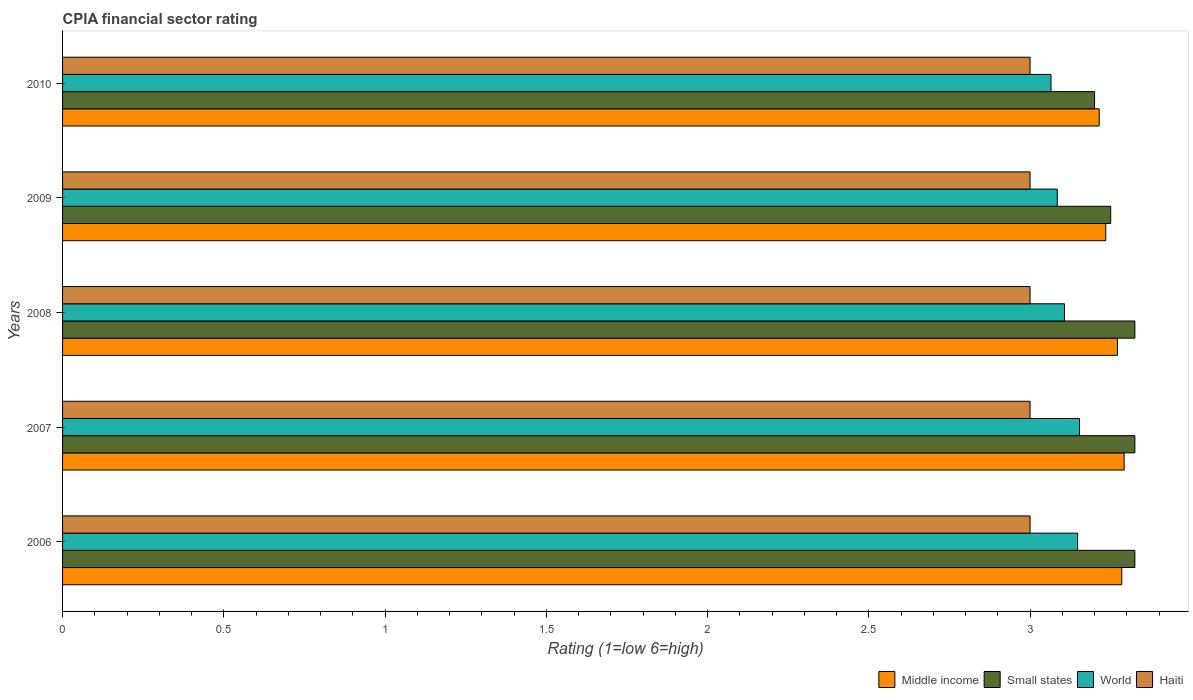Are the number of bars per tick equal to the number of legend labels?
Offer a terse response. Yes. In how many cases, is the number of bars for a given year not equal to the number of legend labels?
Make the answer very short. 0. What is the CPIA rating in World in 2008?
Your answer should be very brief. 3.11. Across all years, what is the maximum CPIA rating in Small states?
Offer a terse response. 3.33. Across all years, what is the minimum CPIA rating in Haiti?
Your response must be concise. 3. In which year was the CPIA rating in World maximum?
Give a very brief answer. 2007. What is the total CPIA rating in Middle income in the graph?
Your response must be concise. 16.3. What is the difference between the CPIA rating in Small states in 2007 and that in 2009?
Make the answer very short. 0.08. What is the difference between the CPIA rating in Middle income in 2009 and the CPIA rating in Small states in 2007?
Your answer should be very brief. -0.09. What is the average CPIA rating in Small states per year?
Offer a very short reply. 3.29. In the year 2008, what is the difference between the CPIA rating in World and CPIA rating in Haiti?
Your response must be concise. 0.11. What is the ratio of the CPIA rating in Small states in 2006 to that in 2007?
Your response must be concise. 1. Is the CPIA rating in World in 2006 less than that in 2007?
Ensure brevity in your answer.  Yes. Is the difference between the CPIA rating in World in 2009 and 2010 greater than the difference between the CPIA rating in Haiti in 2009 and 2010?
Your answer should be compact. Yes. What is the difference between the highest and the second highest CPIA rating in Haiti?
Your answer should be very brief. 0. Is it the case that in every year, the sum of the CPIA rating in Small states and CPIA rating in World is greater than the sum of CPIA rating in Haiti and CPIA rating in Middle income?
Make the answer very short. Yes. What does the 4th bar from the top in 2007 represents?
Make the answer very short. Middle income. Is it the case that in every year, the sum of the CPIA rating in Haiti and CPIA rating in Middle income is greater than the CPIA rating in Small states?
Ensure brevity in your answer.  Yes. How many bars are there?
Give a very brief answer. 20. What is the difference between two consecutive major ticks on the X-axis?
Keep it short and to the point. 0.5. Are the values on the major ticks of X-axis written in scientific E-notation?
Offer a terse response. No. Does the graph contain any zero values?
Ensure brevity in your answer.  No. Where does the legend appear in the graph?
Offer a terse response. Bottom right. How many legend labels are there?
Your response must be concise. 4. What is the title of the graph?
Ensure brevity in your answer.  CPIA financial sector rating. Does "Palau" appear as one of the legend labels in the graph?
Provide a succinct answer. No. What is the label or title of the X-axis?
Your answer should be compact. Rating (1=low 6=high). What is the label or title of the Y-axis?
Keep it short and to the point. Years. What is the Rating (1=low 6=high) of Middle income in 2006?
Keep it short and to the point. 3.28. What is the Rating (1=low 6=high) of Small states in 2006?
Your response must be concise. 3.33. What is the Rating (1=low 6=high) of World in 2006?
Make the answer very short. 3.15. What is the Rating (1=low 6=high) in Haiti in 2006?
Give a very brief answer. 3. What is the Rating (1=low 6=high) of Middle income in 2007?
Provide a succinct answer. 3.29. What is the Rating (1=low 6=high) in Small states in 2007?
Offer a terse response. 3.33. What is the Rating (1=low 6=high) in World in 2007?
Make the answer very short. 3.15. What is the Rating (1=low 6=high) of Middle income in 2008?
Your answer should be compact. 3.27. What is the Rating (1=low 6=high) of Small states in 2008?
Offer a very short reply. 3.33. What is the Rating (1=low 6=high) of World in 2008?
Your response must be concise. 3.11. What is the Rating (1=low 6=high) in Middle income in 2009?
Provide a succinct answer. 3.23. What is the Rating (1=low 6=high) of World in 2009?
Give a very brief answer. 3.08. What is the Rating (1=low 6=high) in Haiti in 2009?
Your answer should be compact. 3. What is the Rating (1=low 6=high) in Middle income in 2010?
Give a very brief answer. 3.21. What is the Rating (1=low 6=high) in Small states in 2010?
Provide a short and direct response. 3.2. What is the Rating (1=low 6=high) of World in 2010?
Provide a succinct answer. 3.06. What is the Rating (1=low 6=high) in Haiti in 2010?
Make the answer very short. 3. Across all years, what is the maximum Rating (1=low 6=high) of Middle income?
Your answer should be very brief. 3.29. Across all years, what is the maximum Rating (1=low 6=high) in Small states?
Offer a terse response. 3.33. Across all years, what is the maximum Rating (1=low 6=high) of World?
Your answer should be very brief. 3.15. Across all years, what is the minimum Rating (1=low 6=high) in Middle income?
Make the answer very short. 3.21. Across all years, what is the minimum Rating (1=low 6=high) in Small states?
Your answer should be compact. 3.2. Across all years, what is the minimum Rating (1=low 6=high) of World?
Your answer should be compact. 3.06. Across all years, what is the minimum Rating (1=low 6=high) of Haiti?
Provide a succinct answer. 3. What is the total Rating (1=low 6=high) in Middle income in the graph?
Your answer should be compact. 16.3. What is the total Rating (1=low 6=high) of Small states in the graph?
Your answer should be very brief. 16.43. What is the total Rating (1=low 6=high) of World in the graph?
Your response must be concise. 15.56. What is the difference between the Rating (1=low 6=high) of Middle income in 2006 and that in 2007?
Ensure brevity in your answer.  -0.01. What is the difference between the Rating (1=low 6=high) in World in 2006 and that in 2007?
Give a very brief answer. -0.01. What is the difference between the Rating (1=low 6=high) in Haiti in 2006 and that in 2007?
Provide a succinct answer. 0. What is the difference between the Rating (1=low 6=high) in Middle income in 2006 and that in 2008?
Ensure brevity in your answer.  0.01. What is the difference between the Rating (1=low 6=high) of World in 2006 and that in 2008?
Keep it short and to the point. 0.04. What is the difference between the Rating (1=low 6=high) in Haiti in 2006 and that in 2008?
Provide a short and direct response. 0. What is the difference between the Rating (1=low 6=high) in Middle income in 2006 and that in 2009?
Keep it short and to the point. 0.05. What is the difference between the Rating (1=low 6=high) in Small states in 2006 and that in 2009?
Ensure brevity in your answer.  0.07. What is the difference between the Rating (1=low 6=high) in World in 2006 and that in 2009?
Make the answer very short. 0.06. What is the difference between the Rating (1=low 6=high) in Haiti in 2006 and that in 2009?
Your answer should be very brief. 0. What is the difference between the Rating (1=low 6=high) in Middle income in 2006 and that in 2010?
Provide a short and direct response. 0.07. What is the difference between the Rating (1=low 6=high) in World in 2006 and that in 2010?
Give a very brief answer. 0.08. What is the difference between the Rating (1=low 6=high) of Middle income in 2007 and that in 2008?
Your answer should be compact. 0.02. What is the difference between the Rating (1=low 6=high) of World in 2007 and that in 2008?
Offer a very short reply. 0.05. What is the difference between the Rating (1=low 6=high) of Middle income in 2007 and that in 2009?
Ensure brevity in your answer.  0.06. What is the difference between the Rating (1=low 6=high) in Small states in 2007 and that in 2009?
Your answer should be very brief. 0.07. What is the difference between the Rating (1=low 6=high) of World in 2007 and that in 2009?
Keep it short and to the point. 0.07. What is the difference between the Rating (1=low 6=high) of Middle income in 2007 and that in 2010?
Your answer should be very brief. 0.08. What is the difference between the Rating (1=low 6=high) in Small states in 2007 and that in 2010?
Give a very brief answer. 0.12. What is the difference between the Rating (1=low 6=high) of World in 2007 and that in 2010?
Provide a short and direct response. 0.09. What is the difference between the Rating (1=low 6=high) of Middle income in 2008 and that in 2009?
Provide a short and direct response. 0.04. What is the difference between the Rating (1=low 6=high) in Small states in 2008 and that in 2009?
Offer a terse response. 0.07. What is the difference between the Rating (1=low 6=high) of World in 2008 and that in 2009?
Offer a very short reply. 0.02. What is the difference between the Rating (1=low 6=high) of Haiti in 2008 and that in 2009?
Keep it short and to the point. 0. What is the difference between the Rating (1=low 6=high) in Middle income in 2008 and that in 2010?
Provide a succinct answer. 0.06. What is the difference between the Rating (1=low 6=high) in World in 2008 and that in 2010?
Give a very brief answer. 0.04. What is the difference between the Rating (1=low 6=high) of Middle income in 2009 and that in 2010?
Keep it short and to the point. 0.02. What is the difference between the Rating (1=low 6=high) in World in 2009 and that in 2010?
Your answer should be compact. 0.02. What is the difference between the Rating (1=low 6=high) in Haiti in 2009 and that in 2010?
Ensure brevity in your answer.  0. What is the difference between the Rating (1=low 6=high) in Middle income in 2006 and the Rating (1=low 6=high) in Small states in 2007?
Keep it short and to the point. -0.04. What is the difference between the Rating (1=low 6=high) in Middle income in 2006 and the Rating (1=low 6=high) in World in 2007?
Your answer should be very brief. 0.13. What is the difference between the Rating (1=low 6=high) of Middle income in 2006 and the Rating (1=low 6=high) of Haiti in 2007?
Your answer should be very brief. 0.28. What is the difference between the Rating (1=low 6=high) of Small states in 2006 and the Rating (1=low 6=high) of World in 2007?
Give a very brief answer. 0.17. What is the difference between the Rating (1=low 6=high) of Small states in 2006 and the Rating (1=low 6=high) of Haiti in 2007?
Your answer should be compact. 0.33. What is the difference between the Rating (1=low 6=high) of World in 2006 and the Rating (1=low 6=high) of Haiti in 2007?
Make the answer very short. 0.15. What is the difference between the Rating (1=low 6=high) of Middle income in 2006 and the Rating (1=low 6=high) of Small states in 2008?
Your answer should be very brief. -0.04. What is the difference between the Rating (1=low 6=high) in Middle income in 2006 and the Rating (1=low 6=high) in World in 2008?
Keep it short and to the point. 0.18. What is the difference between the Rating (1=low 6=high) in Middle income in 2006 and the Rating (1=low 6=high) in Haiti in 2008?
Offer a very short reply. 0.28. What is the difference between the Rating (1=low 6=high) of Small states in 2006 and the Rating (1=low 6=high) of World in 2008?
Your answer should be compact. 0.22. What is the difference between the Rating (1=low 6=high) in Small states in 2006 and the Rating (1=low 6=high) in Haiti in 2008?
Provide a succinct answer. 0.33. What is the difference between the Rating (1=low 6=high) of World in 2006 and the Rating (1=low 6=high) of Haiti in 2008?
Make the answer very short. 0.15. What is the difference between the Rating (1=low 6=high) of Middle income in 2006 and the Rating (1=low 6=high) of Small states in 2009?
Offer a very short reply. 0.03. What is the difference between the Rating (1=low 6=high) in Middle income in 2006 and the Rating (1=low 6=high) in World in 2009?
Offer a terse response. 0.2. What is the difference between the Rating (1=low 6=high) of Middle income in 2006 and the Rating (1=low 6=high) of Haiti in 2009?
Your response must be concise. 0.28. What is the difference between the Rating (1=low 6=high) in Small states in 2006 and the Rating (1=low 6=high) in World in 2009?
Your answer should be compact. 0.24. What is the difference between the Rating (1=low 6=high) in Small states in 2006 and the Rating (1=low 6=high) in Haiti in 2009?
Your response must be concise. 0.33. What is the difference between the Rating (1=low 6=high) in World in 2006 and the Rating (1=low 6=high) in Haiti in 2009?
Give a very brief answer. 0.15. What is the difference between the Rating (1=low 6=high) in Middle income in 2006 and the Rating (1=low 6=high) in Small states in 2010?
Provide a short and direct response. 0.08. What is the difference between the Rating (1=low 6=high) of Middle income in 2006 and the Rating (1=low 6=high) of World in 2010?
Offer a very short reply. 0.22. What is the difference between the Rating (1=low 6=high) in Middle income in 2006 and the Rating (1=low 6=high) in Haiti in 2010?
Make the answer very short. 0.28. What is the difference between the Rating (1=low 6=high) of Small states in 2006 and the Rating (1=low 6=high) of World in 2010?
Offer a very short reply. 0.26. What is the difference between the Rating (1=low 6=high) of Small states in 2006 and the Rating (1=low 6=high) of Haiti in 2010?
Give a very brief answer. 0.33. What is the difference between the Rating (1=low 6=high) in World in 2006 and the Rating (1=low 6=high) in Haiti in 2010?
Give a very brief answer. 0.15. What is the difference between the Rating (1=low 6=high) in Middle income in 2007 and the Rating (1=low 6=high) in Small states in 2008?
Keep it short and to the point. -0.03. What is the difference between the Rating (1=low 6=high) in Middle income in 2007 and the Rating (1=low 6=high) in World in 2008?
Your answer should be compact. 0.18. What is the difference between the Rating (1=low 6=high) of Middle income in 2007 and the Rating (1=low 6=high) of Haiti in 2008?
Your answer should be very brief. 0.29. What is the difference between the Rating (1=low 6=high) of Small states in 2007 and the Rating (1=low 6=high) of World in 2008?
Give a very brief answer. 0.22. What is the difference between the Rating (1=low 6=high) of Small states in 2007 and the Rating (1=low 6=high) of Haiti in 2008?
Your answer should be very brief. 0.33. What is the difference between the Rating (1=low 6=high) of World in 2007 and the Rating (1=low 6=high) of Haiti in 2008?
Provide a short and direct response. 0.15. What is the difference between the Rating (1=low 6=high) of Middle income in 2007 and the Rating (1=low 6=high) of Small states in 2009?
Provide a short and direct response. 0.04. What is the difference between the Rating (1=low 6=high) of Middle income in 2007 and the Rating (1=low 6=high) of World in 2009?
Your answer should be compact. 0.21. What is the difference between the Rating (1=low 6=high) in Middle income in 2007 and the Rating (1=low 6=high) in Haiti in 2009?
Your answer should be very brief. 0.29. What is the difference between the Rating (1=low 6=high) in Small states in 2007 and the Rating (1=low 6=high) in World in 2009?
Provide a succinct answer. 0.24. What is the difference between the Rating (1=low 6=high) in Small states in 2007 and the Rating (1=low 6=high) in Haiti in 2009?
Your answer should be very brief. 0.33. What is the difference between the Rating (1=low 6=high) of World in 2007 and the Rating (1=low 6=high) of Haiti in 2009?
Your answer should be very brief. 0.15. What is the difference between the Rating (1=low 6=high) of Middle income in 2007 and the Rating (1=low 6=high) of Small states in 2010?
Make the answer very short. 0.09. What is the difference between the Rating (1=low 6=high) in Middle income in 2007 and the Rating (1=low 6=high) in World in 2010?
Your response must be concise. 0.23. What is the difference between the Rating (1=low 6=high) in Middle income in 2007 and the Rating (1=low 6=high) in Haiti in 2010?
Ensure brevity in your answer.  0.29. What is the difference between the Rating (1=low 6=high) in Small states in 2007 and the Rating (1=low 6=high) in World in 2010?
Make the answer very short. 0.26. What is the difference between the Rating (1=low 6=high) of Small states in 2007 and the Rating (1=low 6=high) of Haiti in 2010?
Give a very brief answer. 0.33. What is the difference between the Rating (1=low 6=high) of World in 2007 and the Rating (1=low 6=high) of Haiti in 2010?
Ensure brevity in your answer.  0.15. What is the difference between the Rating (1=low 6=high) of Middle income in 2008 and the Rating (1=low 6=high) of Small states in 2009?
Make the answer very short. 0.02. What is the difference between the Rating (1=low 6=high) of Middle income in 2008 and the Rating (1=low 6=high) of World in 2009?
Provide a succinct answer. 0.19. What is the difference between the Rating (1=low 6=high) in Middle income in 2008 and the Rating (1=low 6=high) in Haiti in 2009?
Make the answer very short. 0.27. What is the difference between the Rating (1=low 6=high) in Small states in 2008 and the Rating (1=low 6=high) in World in 2009?
Your answer should be very brief. 0.24. What is the difference between the Rating (1=low 6=high) of Small states in 2008 and the Rating (1=low 6=high) of Haiti in 2009?
Provide a succinct answer. 0.33. What is the difference between the Rating (1=low 6=high) of World in 2008 and the Rating (1=low 6=high) of Haiti in 2009?
Make the answer very short. 0.11. What is the difference between the Rating (1=low 6=high) of Middle income in 2008 and the Rating (1=low 6=high) of Small states in 2010?
Provide a succinct answer. 0.07. What is the difference between the Rating (1=low 6=high) of Middle income in 2008 and the Rating (1=low 6=high) of World in 2010?
Keep it short and to the point. 0.21. What is the difference between the Rating (1=low 6=high) in Middle income in 2008 and the Rating (1=low 6=high) in Haiti in 2010?
Make the answer very short. 0.27. What is the difference between the Rating (1=low 6=high) of Small states in 2008 and the Rating (1=low 6=high) of World in 2010?
Provide a short and direct response. 0.26. What is the difference between the Rating (1=low 6=high) of Small states in 2008 and the Rating (1=low 6=high) of Haiti in 2010?
Offer a terse response. 0.33. What is the difference between the Rating (1=low 6=high) in World in 2008 and the Rating (1=low 6=high) in Haiti in 2010?
Provide a short and direct response. 0.11. What is the difference between the Rating (1=low 6=high) in Middle income in 2009 and the Rating (1=low 6=high) in Small states in 2010?
Your answer should be very brief. 0.03. What is the difference between the Rating (1=low 6=high) in Middle income in 2009 and the Rating (1=low 6=high) in World in 2010?
Keep it short and to the point. 0.17. What is the difference between the Rating (1=low 6=high) in Middle income in 2009 and the Rating (1=low 6=high) in Haiti in 2010?
Make the answer very short. 0.23. What is the difference between the Rating (1=low 6=high) of Small states in 2009 and the Rating (1=low 6=high) of World in 2010?
Your answer should be very brief. 0.19. What is the difference between the Rating (1=low 6=high) in Small states in 2009 and the Rating (1=low 6=high) in Haiti in 2010?
Ensure brevity in your answer.  0.25. What is the difference between the Rating (1=low 6=high) of World in 2009 and the Rating (1=low 6=high) of Haiti in 2010?
Offer a very short reply. 0.08. What is the average Rating (1=low 6=high) of Middle income per year?
Ensure brevity in your answer.  3.26. What is the average Rating (1=low 6=high) of Small states per year?
Ensure brevity in your answer.  3.29. What is the average Rating (1=low 6=high) in World per year?
Make the answer very short. 3.11. In the year 2006, what is the difference between the Rating (1=low 6=high) in Middle income and Rating (1=low 6=high) in Small states?
Keep it short and to the point. -0.04. In the year 2006, what is the difference between the Rating (1=low 6=high) of Middle income and Rating (1=low 6=high) of World?
Keep it short and to the point. 0.14. In the year 2006, what is the difference between the Rating (1=low 6=high) of Middle income and Rating (1=low 6=high) of Haiti?
Your response must be concise. 0.28. In the year 2006, what is the difference between the Rating (1=low 6=high) in Small states and Rating (1=low 6=high) in World?
Keep it short and to the point. 0.18. In the year 2006, what is the difference between the Rating (1=low 6=high) of Small states and Rating (1=low 6=high) of Haiti?
Ensure brevity in your answer.  0.33. In the year 2006, what is the difference between the Rating (1=low 6=high) in World and Rating (1=low 6=high) in Haiti?
Provide a short and direct response. 0.15. In the year 2007, what is the difference between the Rating (1=low 6=high) in Middle income and Rating (1=low 6=high) in Small states?
Provide a succinct answer. -0.03. In the year 2007, what is the difference between the Rating (1=low 6=high) in Middle income and Rating (1=low 6=high) in World?
Give a very brief answer. 0.14. In the year 2007, what is the difference between the Rating (1=low 6=high) of Middle income and Rating (1=low 6=high) of Haiti?
Offer a very short reply. 0.29. In the year 2007, what is the difference between the Rating (1=low 6=high) in Small states and Rating (1=low 6=high) in World?
Offer a very short reply. 0.17. In the year 2007, what is the difference between the Rating (1=low 6=high) in Small states and Rating (1=low 6=high) in Haiti?
Your response must be concise. 0.33. In the year 2007, what is the difference between the Rating (1=low 6=high) in World and Rating (1=low 6=high) in Haiti?
Give a very brief answer. 0.15. In the year 2008, what is the difference between the Rating (1=low 6=high) of Middle income and Rating (1=low 6=high) of Small states?
Provide a short and direct response. -0.05. In the year 2008, what is the difference between the Rating (1=low 6=high) in Middle income and Rating (1=low 6=high) in World?
Ensure brevity in your answer.  0.16. In the year 2008, what is the difference between the Rating (1=low 6=high) of Middle income and Rating (1=low 6=high) of Haiti?
Give a very brief answer. 0.27. In the year 2008, what is the difference between the Rating (1=low 6=high) of Small states and Rating (1=low 6=high) of World?
Your answer should be very brief. 0.22. In the year 2008, what is the difference between the Rating (1=low 6=high) in Small states and Rating (1=low 6=high) in Haiti?
Offer a very short reply. 0.33. In the year 2008, what is the difference between the Rating (1=low 6=high) in World and Rating (1=low 6=high) in Haiti?
Provide a succinct answer. 0.11. In the year 2009, what is the difference between the Rating (1=low 6=high) of Middle income and Rating (1=low 6=high) of Small states?
Give a very brief answer. -0.02. In the year 2009, what is the difference between the Rating (1=low 6=high) of Middle income and Rating (1=low 6=high) of World?
Provide a succinct answer. 0.15. In the year 2009, what is the difference between the Rating (1=low 6=high) in Middle income and Rating (1=low 6=high) in Haiti?
Your answer should be compact. 0.23. In the year 2009, what is the difference between the Rating (1=low 6=high) of Small states and Rating (1=low 6=high) of World?
Your answer should be compact. 0.17. In the year 2009, what is the difference between the Rating (1=low 6=high) in World and Rating (1=low 6=high) in Haiti?
Your answer should be very brief. 0.08. In the year 2010, what is the difference between the Rating (1=low 6=high) in Middle income and Rating (1=low 6=high) in Small states?
Your answer should be compact. 0.01. In the year 2010, what is the difference between the Rating (1=low 6=high) in Middle income and Rating (1=low 6=high) in World?
Make the answer very short. 0.15. In the year 2010, what is the difference between the Rating (1=low 6=high) of Middle income and Rating (1=low 6=high) of Haiti?
Give a very brief answer. 0.21. In the year 2010, what is the difference between the Rating (1=low 6=high) of Small states and Rating (1=low 6=high) of World?
Your answer should be compact. 0.14. In the year 2010, what is the difference between the Rating (1=low 6=high) in Small states and Rating (1=low 6=high) in Haiti?
Ensure brevity in your answer.  0.2. In the year 2010, what is the difference between the Rating (1=low 6=high) of World and Rating (1=low 6=high) of Haiti?
Make the answer very short. 0.06. What is the ratio of the Rating (1=low 6=high) of World in 2006 to that in 2007?
Ensure brevity in your answer.  1. What is the ratio of the Rating (1=low 6=high) in Middle income in 2006 to that in 2008?
Give a very brief answer. 1. What is the ratio of the Rating (1=low 6=high) of World in 2006 to that in 2008?
Your response must be concise. 1.01. What is the ratio of the Rating (1=low 6=high) in Haiti in 2006 to that in 2008?
Give a very brief answer. 1. What is the ratio of the Rating (1=low 6=high) of Middle income in 2006 to that in 2009?
Provide a succinct answer. 1.02. What is the ratio of the Rating (1=low 6=high) in Small states in 2006 to that in 2009?
Your answer should be very brief. 1.02. What is the ratio of the Rating (1=low 6=high) of World in 2006 to that in 2009?
Offer a very short reply. 1.02. What is the ratio of the Rating (1=low 6=high) in Middle income in 2006 to that in 2010?
Offer a very short reply. 1.02. What is the ratio of the Rating (1=low 6=high) of Small states in 2006 to that in 2010?
Your response must be concise. 1.04. What is the ratio of the Rating (1=low 6=high) in World in 2006 to that in 2010?
Your answer should be compact. 1.03. What is the ratio of the Rating (1=low 6=high) of Middle income in 2007 to that in 2008?
Keep it short and to the point. 1.01. What is the ratio of the Rating (1=low 6=high) in Small states in 2007 to that in 2008?
Your answer should be very brief. 1. What is the ratio of the Rating (1=low 6=high) of World in 2007 to that in 2008?
Make the answer very short. 1.01. What is the ratio of the Rating (1=low 6=high) in Haiti in 2007 to that in 2008?
Offer a very short reply. 1. What is the ratio of the Rating (1=low 6=high) in Middle income in 2007 to that in 2009?
Provide a short and direct response. 1.02. What is the ratio of the Rating (1=low 6=high) in Small states in 2007 to that in 2009?
Make the answer very short. 1.02. What is the ratio of the Rating (1=low 6=high) in World in 2007 to that in 2009?
Keep it short and to the point. 1.02. What is the ratio of the Rating (1=low 6=high) of Middle income in 2007 to that in 2010?
Your response must be concise. 1.02. What is the ratio of the Rating (1=low 6=high) of Small states in 2007 to that in 2010?
Provide a succinct answer. 1.04. What is the ratio of the Rating (1=low 6=high) in World in 2007 to that in 2010?
Give a very brief answer. 1.03. What is the ratio of the Rating (1=low 6=high) in Middle income in 2008 to that in 2009?
Provide a short and direct response. 1.01. What is the ratio of the Rating (1=low 6=high) of Small states in 2008 to that in 2009?
Ensure brevity in your answer.  1.02. What is the ratio of the Rating (1=low 6=high) of World in 2008 to that in 2009?
Provide a succinct answer. 1.01. What is the ratio of the Rating (1=low 6=high) in Haiti in 2008 to that in 2009?
Your answer should be very brief. 1. What is the ratio of the Rating (1=low 6=high) of Middle income in 2008 to that in 2010?
Keep it short and to the point. 1.02. What is the ratio of the Rating (1=low 6=high) in Small states in 2008 to that in 2010?
Your response must be concise. 1.04. What is the ratio of the Rating (1=low 6=high) of World in 2008 to that in 2010?
Provide a succinct answer. 1.01. What is the ratio of the Rating (1=low 6=high) of Haiti in 2008 to that in 2010?
Provide a succinct answer. 1. What is the ratio of the Rating (1=low 6=high) in Small states in 2009 to that in 2010?
Ensure brevity in your answer.  1.02. What is the ratio of the Rating (1=low 6=high) in World in 2009 to that in 2010?
Provide a short and direct response. 1.01. What is the difference between the highest and the second highest Rating (1=low 6=high) in Middle income?
Offer a very short reply. 0.01. What is the difference between the highest and the second highest Rating (1=low 6=high) in Small states?
Provide a short and direct response. 0. What is the difference between the highest and the second highest Rating (1=low 6=high) of World?
Make the answer very short. 0.01. What is the difference between the highest and the second highest Rating (1=low 6=high) in Haiti?
Offer a terse response. 0. What is the difference between the highest and the lowest Rating (1=low 6=high) of Middle income?
Offer a terse response. 0.08. What is the difference between the highest and the lowest Rating (1=low 6=high) of World?
Make the answer very short. 0.09. 